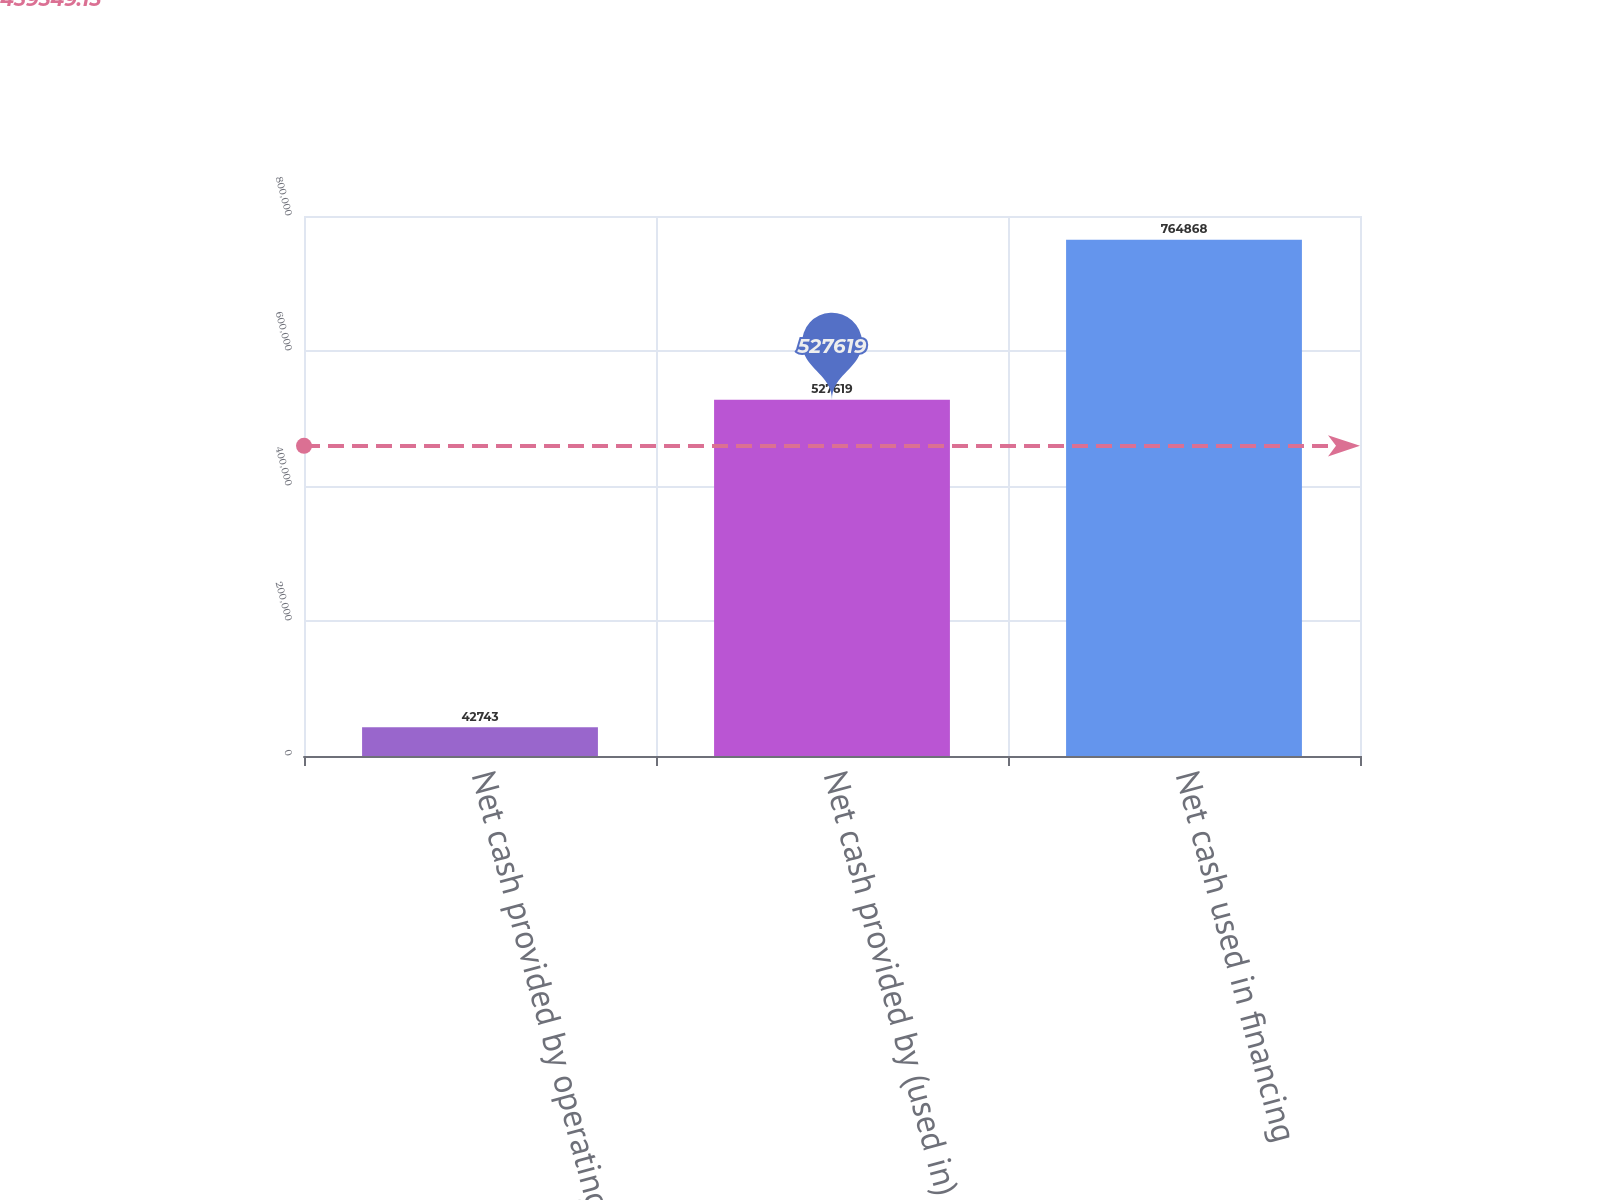Convert chart to OTSL. <chart><loc_0><loc_0><loc_500><loc_500><bar_chart><fcel>Net cash provided by operating<fcel>Net cash provided by (used in)<fcel>Net cash used in financing<nl><fcel>42743<fcel>527619<fcel>764868<nl></chart> 